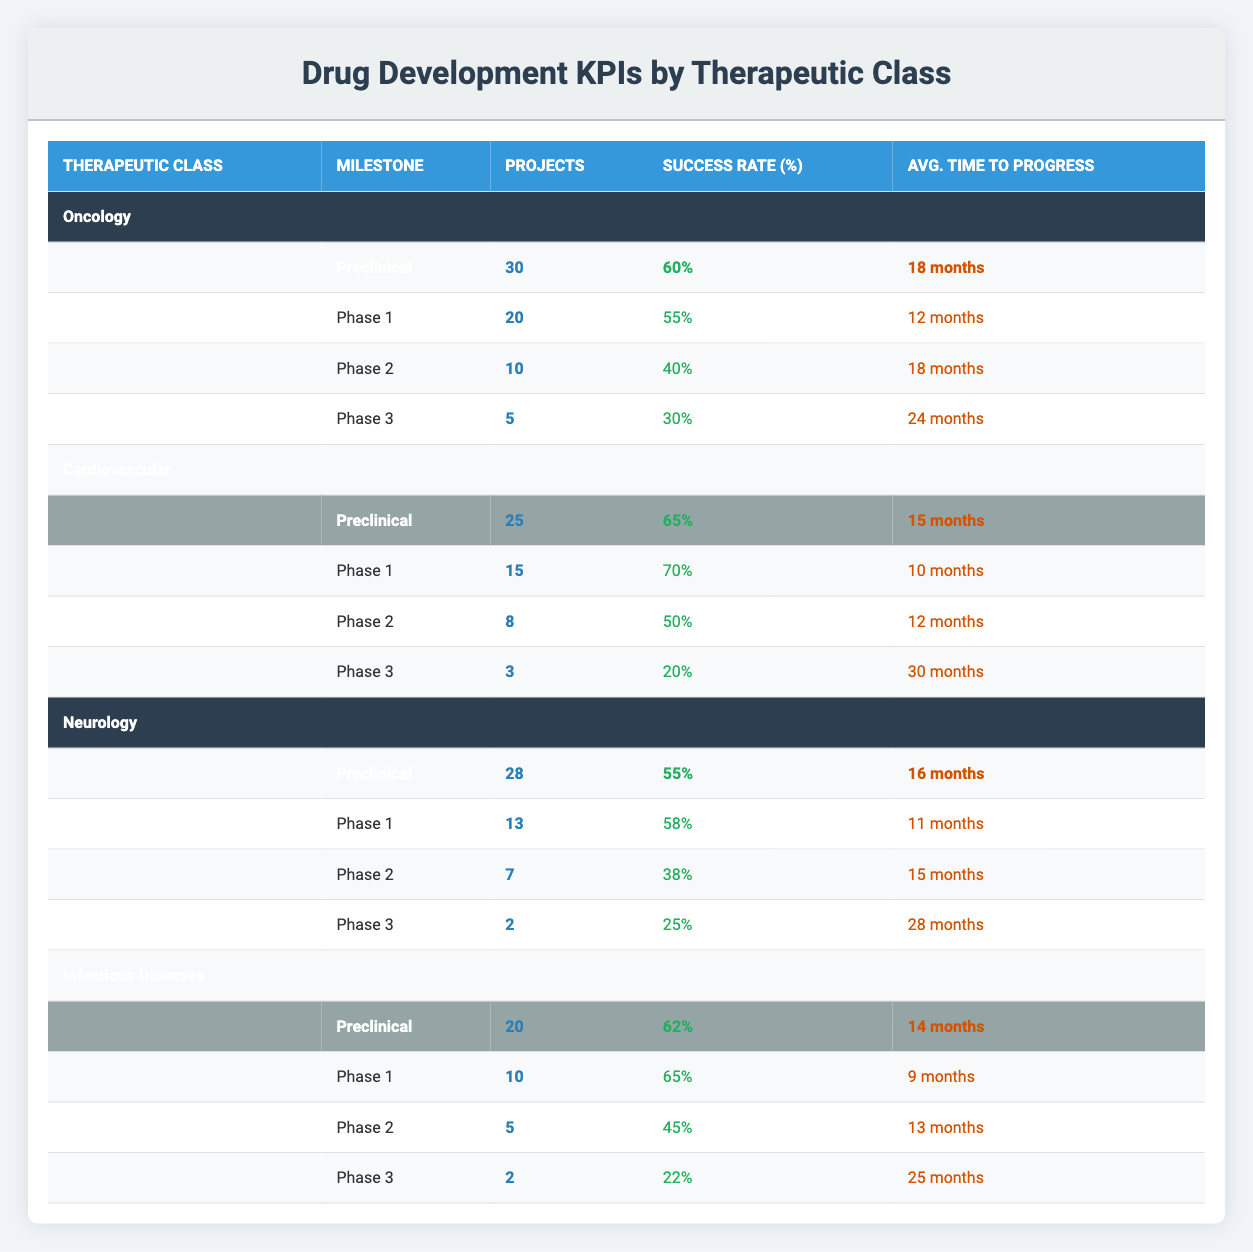What is the success rate of projects in Phase 2 for Neurology? The success rate of projects in Phase 2 for Neurology is listed in the table under the Neurology section, specifically under Phase 2, which shows a success rate of 38%.
Answer: 38% How many projects are in the Phase 1 milestone for Infectious Diseases? In the Infectious Diseases section of the table, the Phase 1 milestone indicates there are 10 projects.
Answer: 10 Which therapeutic class has the highest average success rate at the Preclinical milestone? The Preclinical success rates are 60% for Oncology, 65% for Cardiovascular, 55% for Neurology, and 62% for Infectious Diseases. Cardiovascular has the highest success rate at 65%.
Answer: Cardiovascular What is the average time to progress for Cardiovascular projects from Phase 2 and Phase 3? The average time to progress from Phase 2 is 12 months and from Phase 3 is 30 months. To determine the average: (12 + 30) / 2 = 21 months.
Answer: 21 months Is it true that Oncology has the same number of projects in Preclinical and Phase 1 milestones? According to the table, Oncology has 30 projects in Preclinical and 20 projects in Phase 1. Since these values are different, the statement is false.
Answer: No Which therapeutic class has the lowest overall success rate in Phase 3? The Phase 3 success rates for each class are 30% (Oncology), 20% (Cardiovascular), 25% (Neurology), and 22% (Infectious Diseases). The lowest is 20% for Cardiovascular.
Answer: Cardiovascular How many total projects are in the Preclinical milestones across all therapeutic classes? Summing the projects in the Preclinical milestone: 30 (Oncology) + 25 (Cardiovascular) + 28 (Neurology) + 20 (Infectious Diseases) = 103 projects total.
Answer: 103 How does the success rate for Phase 1 projects in Infectious Diseases compare to that in Oncology? The Phase 1 success rate for Infectious Diseases is 65% while for Oncology, it is 55%. Comparing both, Infectious Diseases has a higher success rate by 10%.
Answer: Infectious Diseases is higher 